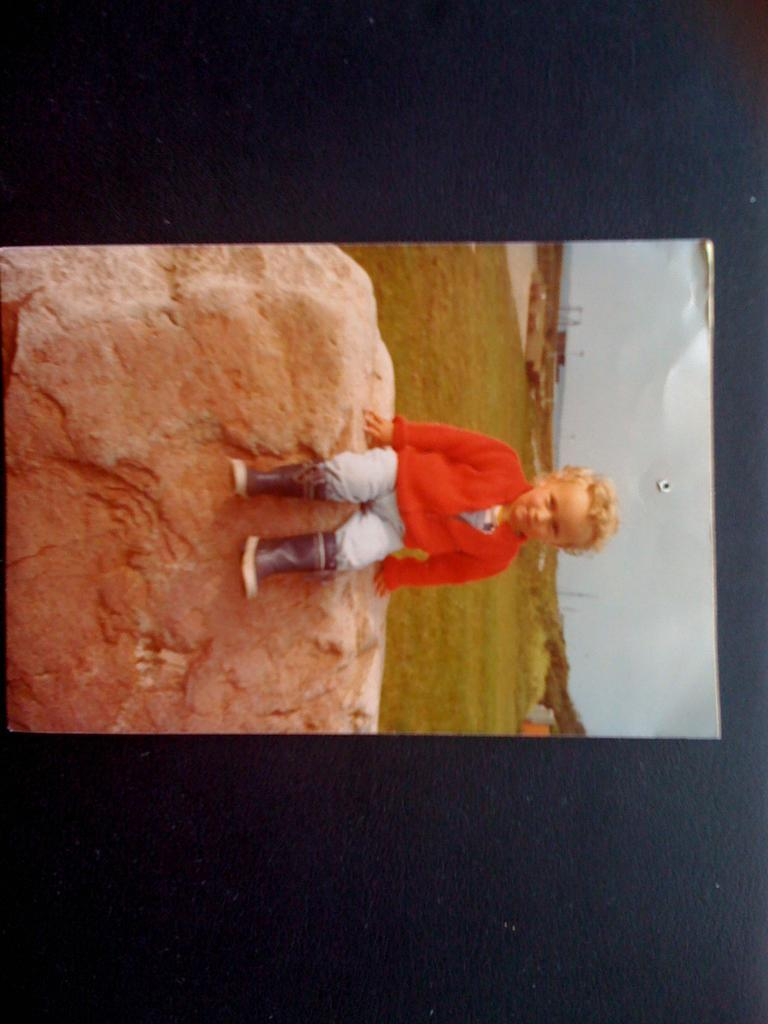What is the main subject of the image? There is a photo on a black surface in the image. What can be seen in the photo? The photo contains a person sitting on a rock. What type of vegetation is visible in the background of the image? There is grass in the background of the image. What other objects can be seen in the background of the image? There are poles in the background of the image. What is visible in the sky in the image? The sky is visible in the background of the image. What rate of growth can be observed in the plantation shown in the image? There is no plantation present in the image; it features a photo of a person sitting on a rock with grass and poles in the background. 